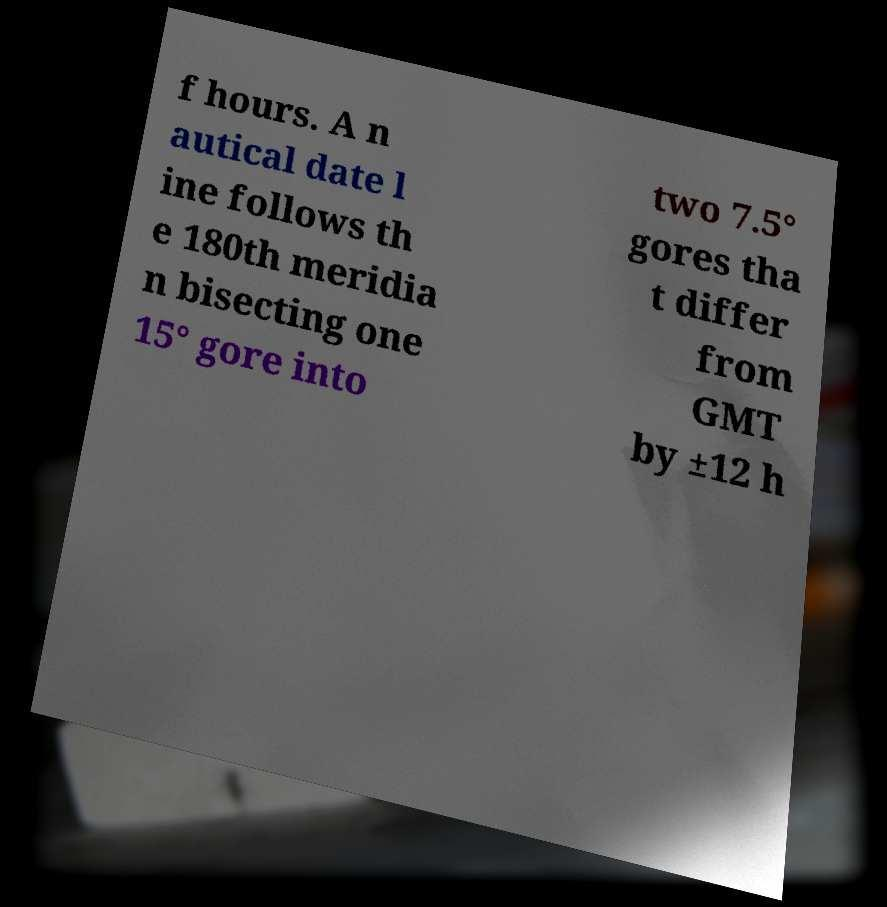Could you extract and type out the text from this image? f hours. A n autical date l ine follows th e 180th meridia n bisecting one 15° gore into two 7.5° gores tha t differ from GMT by ±12 h 